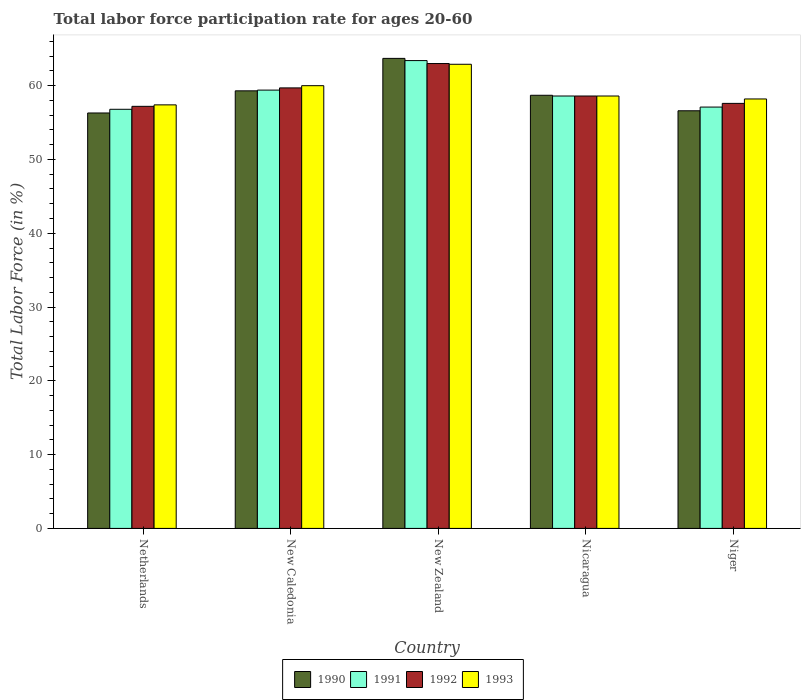How many different coloured bars are there?
Keep it short and to the point. 4. How many groups of bars are there?
Give a very brief answer. 5. Are the number of bars per tick equal to the number of legend labels?
Your response must be concise. Yes. How many bars are there on the 3rd tick from the right?
Provide a short and direct response. 4. What is the label of the 1st group of bars from the left?
Your answer should be very brief. Netherlands. In how many cases, is the number of bars for a given country not equal to the number of legend labels?
Your answer should be very brief. 0. What is the labor force participation rate in 1990 in New Zealand?
Offer a terse response. 63.7. Across all countries, what is the maximum labor force participation rate in 1990?
Keep it short and to the point. 63.7. Across all countries, what is the minimum labor force participation rate in 1991?
Offer a very short reply. 56.8. In which country was the labor force participation rate in 1993 maximum?
Offer a terse response. New Zealand. What is the total labor force participation rate in 1990 in the graph?
Make the answer very short. 294.6. What is the difference between the labor force participation rate in 1990 in New Caledonia and that in Nicaragua?
Your answer should be compact. 0.6. What is the difference between the labor force participation rate in 1990 in Niger and the labor force participation rate in 1992 in New Caledonia?
Offer a terse response. -3.1. What is the average labor force participation rate in 1990 per country?
Give a very brief answer. 58.92. What is the difference between the labor force participation rate of/in 1990 and labor force participation rate of/in 1993 in New Zealand?
Ensure brevity in your answer.  0.8. What is the ratio of the labor force participation rate in 1991 in Netherlands to that in Niger?
Offer a very short reply. 0.99. What is the difference between the highest and the second highest labor force participation rate in 1991?
Your answer should be very brief. -0.8. Is it the case that in every country, the sum of the labor force participation rate in 1993 and labor force participation rate in 1991 is greater than the sum of labor force participation rate in 1992 and labor force participation rate in 1990?
Your answer should be very brief. No. How many bars are there?
Your response must be concise. 20. Are all the bars in the graph horizontal?
Offer a terse response. No. How many countries are there in the graph?
Ensure brevity in your answer.  5. What is the difference between two consecutive major ticks on the Y-axis?
Offer a terse response. 10. Does the graph contain any zero values?
Offer a very short reply. No. Where does the legend appear in the graph?
Offer a terse response. Bottom center. How many legend labels are there?
Your answer should be compact. 4. What is the title of the graph?
Keep it short and to the point. Total labor force participation rate for ages 20-60. Does "2008" appear as one of the legend labels in the graph?
Offer a very short reply. No. What is the Total Labor Force (in %) of 1990 in Netherlands?
Ensure brevity in your answer.  56.3. What is the Total Labor Force (in %) of 1991 in Netherlands?
Give a very brief answer. 56.8. What is the Total Labor Force (in %) in 1992 in Netherlands?
Your response must be concise. 57.2. What is the Total Labor Force (in %) in 1993 in Netherlands?
Offer a very short reply. 57.4. What is the Total Labor Force (in %) in 1990 in New Caledonia?
Your response must be concise. 59.3. What is the Total Labor Force (in %) in 1991 in New Caledonia?
Your answer should be very brief. 59.4. What is the Total Labor Force (in %) in 1992 in New Caledonia?
Offer a terse response. 59.7. What is the Total Labor Force (in %) of 1990 in New Zealand?
Provide a short and direct response. 63.7. What is the Total Labor Force (in %) in 1991 in New Zealand?
Offer a terse response. 63.4. What is the Total Labor Force (in %) of 1992 in New Zealand?
Offer a terse response. 63. What is the Total Labor Force (in %) in 1993 in New Zealand?
Offer a terse response. 62.9. What is the Total Labor Force (in %) of 1990 in Nicaragua?
Ensure brevity in your answer.  58.7. What is the Total Labor Force (in %) in 1991 in Nicaragua?
Offer a terse response. 58.6. What is the Total Labor Force (in %) of 1992 in Nicaragua?
Give a very brief answer. 58.6. What is the Total Labor Force (in %) in 1993 in Nicaragua?
Your answer should be compact. 58.6. What is the Total Labor Force (in %) in 1990 in Niger?
Your response must be concise. 56.6. What is the Total Labor Force (in %) of 1991 in Niger?
Offer a very short reply. 57.1. What is the Total Labor Force (in %) of 1992 in Niger?
Keep it short and to the point. 57.6. What is the Total Labor Force (in %) in 1993 in Niger?
Offer a very short reply. 58.2. Across all countries, what is the maximum Total Labor Force (in %) in 1990?
Make the answer very short. 63.7. Across all countries, what is the maximum Total Labor Force (in %) of 1991?
Keep it short and to the point. 63.4. Across all countries, what is the maximum Total Labor Force (in %) in 1992?
Offer a terse response. 63. Across all countries, what is the maximum Total Labor Force (in %) of 1993?
Your response must be concise. 62.9. Across all countries, what is the minimum Total Labor Force (in %) in 1990?
Keep it short and to the point. 56.3. Across all countries, what is the minimum Total Labor Force (in %) of 1991?
Your answer should be compact. 56.8. Across all countries, what is the minimum Total Labor Force (in %) in 1992?
Offer a terse response. 57.2. Across all countries, what is the minimum Total Labor Force (in %) in 1993?
Your response must be concise. 57.4. What is the total Total Labor Force (in %) of 1990 in the graph?
Offer a terse response. 294.6. What is the total Total Labor Force (in %) in 1991 in the graph?
Your answer should be compact. 295.3. What is the total Total Labor Force (in %) of 1992 in the graph?
Ensure brevity in your answer.  296.1. What is the total Total Labor Force (in %) of 1993 in the graph?
Provide a succinct answer. 297.1. What is the difference between the Total Labor Force (in %) in 1991 in Netherlands and that in New Caledonia?
Offer a very short reply. -2.6. What is the difference between the Total Labor Force (in %) of 1993 in Netherlands and that in New Zealand?
Offer a very short reply. -5.5. What is the difference between the Total Labor Force (in %) of 1991 in Netherlands and that in Nicaragua?
Offer a very short reply. -1.8. What is the difference between the Total Labor Force (in %) in 1992 in Netherlands and that in Nicaragua?
Provide a short and direct response. -1.4. What is the difference between the Total Labor Force (in %) in 1991 in Netherlands and that in Niger?
Keep it short and to the point. -0.3. What is the difference between the Total Labor Force (in %) of 1990 in New Caledonia and that in New Zealand?
Make the answer very short. -4.4. What is the difference between the Total Labor Force (in %) of 1992 in New Caledonia and that in New Zealand?
Offer a very short reply. -3.3. What is the difference between the Total Labor Force (in %) in 1993 in New Caledonia and that in New Zealand?
Offer a terse response. -2.9. What is the difference between the Total Labor Force (in %) in 1991 in New Caledonia and that in Nicaragua?
Your response must be concise. 0.8. What is the difference between the Total Labor Force (in %) of 1993 in New Caledonia and that in Nicaragua?
Your answer should be very brief. 1.4. What is the difference between the Total Labor Force (in %) of 1990 in New Caledonia and that in Niger?
Offer a terse response. 2.7. What is the difference between the Total Labor Force (in %) in 1993 in New Caledonia and that in Niger?
Offer a very short reply. 1.8. What is the difference between the Total Labor Force (in %) in 1990 in New Zealand and that in Nicaragua?
Make the answer very short. 5. What is the difference between the Total Labor Force (in %) in 1991 in New Zealand and that in Nicaragua?
Your response must be concise. 4.8. What is the difference between the Total Labor Force (in %) of 1993 in New Zealand and that in Nicaragua?
Ensure brevity in your answer.  4.3. What is the difference between the Total Labor Force (in %) of 1990 in New Zealand and that in Niger?
Offer a very short reply. 7.1. What is the difference between the Total Labor Force (in %) in 1992 in New Zealand and that in Niger?
Your answer should be compact. 5.4. What is the difference between the Total Labor Force (in %) of 1993 in New Zealand and that in Niger?
Give a very brief answer. 4.7. What is the difference between the Total Labor Force (in %) in 1991 in Nicaragua and that in Niger?
Make the answer very short. 1.5. What is the difference between the Total Labor Force (in %) of 1990 in Netherlands and the Total Labor Force (in %) of 1992 in New Caledonia?
Provide a succinct answer. -3.4. What is the difference between the Total Labor Force (in %) of 1990 in Netherlands and the Total Labor Force (in %) of 1993 in New Caledonia?
Provide a succinct answer. -3.7. What is the difference between the Total Labor Force (in %) in 1992 in Netherlands and the Total Labor Force (in %) in 1993 in New Caledonia?
Offer a very short reply. -2.8. What is the difference between the Total Labor Force (in %) in 1991 in Netherlands and the Total Labor Force (in %) in 1992 in New Zealand?
Offer a terse response. -6.2. What is the difference between the Total Labor Force (in %) of 1990 in Netherlands and the Total Labor Force (in %) of 1991 in Nicaragua?
Give a very brief answer. -2.3. What is the difference between the Total Labor Force (in %) in 1990 in Netherlands and the Total Labor Force (in %) in 1993 in Nicaragua?
Your answer should be compact. -2.3. What is the difference between the Total Labor Force (in %) in 1992 in Netherlands and the Total Labor Force (in %) in 1993 in Nicaragua?
Offer a very short reply. -1.4. What is the difference between the Total Labor Force (in %) of 1990 in Netherlands and the Total Labor Force (in %) of 1992 in Niger?
Make the answer very short. -1.3. What is the difference between the Total Labor Force (in %) in 1990 in Netherlands and the Total Labor Force (in %) in 1993 in Niger?
Your response must be concise. -1.9. What is the difference between the Total Labor Force (in %) in 1991 in Netherlands and the Total Labor Force (in %) in 1992 in Niger?
Your answer should be compact. -0.8. What is the difference between the Total Labor Force (in %) of 1992 in Netherlands and the Total Labor Force (in %) of 1993 in Niger?
Offer a very short reply. -1. What is the difference between the Total Labor Force (in %) of 1990 in New Caledonia and the Total Labor Force (in %) of 1991 in New Zealand?
Provide a short and direct response. -4.1. What is the difference between the Total Labor Force (in %) in 1990 in New Caledonia and the Total Labor Force (in %) in 1992 in New Zealand?
Ensure brevity in your answer.  -3.7. What is the difference between the Total Labor Force (in %) in 1991 in New Caledonia and the Total Labor Force (in %) in 1992 in New Zealand?
Make the answer very short. -3.6. What is the difference between the Total Labor Force (in %) of 1991 in New Caledonia and the Total Labor Force (in %) of 1993 in New Zealand?
Offer a very short reply. -3.5. What is the difference between the Total Labor Force (in %) in 1992 in New Caledonia and the Total Labor Force (in %) in 1993 in New Zealand?
Make the answer very short. -3.2. What is the difference between the Total Labor Force (in %) of 1990 in New Caledonia and the Total Labor Force (in %) of 1991 in Nicaragua?
Provide a succinct answer. 0.7. What is the difference between the Total Labor Force (in %) of 1990 in New Caledonia and the Total Labor Force (in %) of 1993 in Nicaragua?
Make the answer very short. 0.7. What is the difference between the Total Labor Force (in %) of 1991 in New Caledonia and the Total Labor Force (in %) of 1993 in Nicaragua?
Your response must be concise. 0.8. What is the difference between the Total Labor Force (in %) in 1992 in New Caledonia and the Total Labor Force (in %) in 1993 in Nicaragua?
Give a very brief answer. 1.1. What is the difference between the Total Labor Force (in %) in 1990 in New Caledonia and the Total Labor Force (in %) in 1991 in Niger?
Your response must be concise. 2.2. What is the difference between the Total Labor Force (in %) of 1990 in New Caledonia and the Total Labor Force (in %) of 1992 in Niger?
Provide a short and direct response. 1.7. What is the difference between the Total Labor Force (in %) in 1992 in New Caledonia and the Total Labor Force (in %) in 1993 in Niger?
Provide a succinct answer. 1.5. What is the difference between the Total Labor Force (in %) of 1990 in New Zealand and the Total Labor Force (in %) of 1991 in Nicaragua?
Your answer should be very brief. 5.1. What is the difference between the Total Labor Force (in %) in 1990 in New Zealand and the Total Labor Force (in %) in 1992 in Nicaragua?
Your response must be concise. 5.1. What is the difference between the Total Labor Force (in %) in 1990 in New Zealand and the Total Labor Force (in %) in 1993 in Nicaragua?
Your response must be concise. 5.1. What is the difference between the Total Labor Force (in %) of 1991 in New Zealand and the Total Labor Force (in %) of 1993 in Nicaragua?
Make the answer very short. 4.8. What is the difference between the Total Labor Force (in %) of 1990 in New Zealand and the Total Labor Force (in %) of 1993 in Niger?
Your answer should be very brief. 5.5. What is the difference between the Total Labor Force (in %) in 1991 in New Zealand and the Total Labor Force (in %) in 1992 in Niger?
Provide a succinct answer. 5.8. What is the difference between the Total Labor Force (in %) of 1991 in New Zealand and the Total Labor Force (in %) of 1993 in Niger?
Your response must be concise. 5.2. What is the difference between the Total Labor Force (in %) in 1990 in Nicaragua and the Total Labor Force (in %) in 1991 in Niger?
Offer a very short reply. 1.6. What is the difference between the Total Labor Force (in %) in 1990 in Nicaragua and the Total Labor Force (in %) in 1992 in Niger?
Your response must be concise. 1.1. What is the difference between the Total Labor Force (in %) in 1990 in Nicaragua and the Total Labor Force (in %) in 1993 in Niger?
Your answer should be compact. 0.5. What is the difference between the Total Labor Force (in %) in 1991 in Nicaragua and the Total Labor Force (in %) in 1993 in Niger?
Your answer should be very brief. 0.4. What is the average Total Labor Force (in %) of 1990 per country?
Your response must be concise. 58.92. What is the average Total Labor Force (in %) of 1991 per country?
Give a very brief answer. 59.06. What is the average Total Labor Force (in %) in 1992 per country?
Give a very brief answer. 59.22. What is the average Total Labor Force (in %) of 1993 per country?
Keep it short and to the point. 59.42. What is the difference between the Total Labor Force (in %) in 1990 and Total Labor Force (in %) in 1991 in Netherlands?
Make the answer very short. -0.5. What is the difference between the Total Labor Force (in %) in 1990 and Total Labor Force (in %) in 1992 in Netherlands?
Ensure brevity in your answer.  -0.9. What is the difference between the Total Labor Force (in %) of 1990 and Total Labor Force (in %) of 1993 in Netherlands?
Give a very brief answer. -1.1. What is the difference between the Total Labor Force (in %) in 1990 and Total Labor Force (in %) in 1992 in New Caledonia?
Ensure brevity in your answer.  -0.4. What is the difference between the Total Labor Force (in %) of 1990 and Total Labor Force (in %) of 1993 in New Caledonia?
Offer a terse response. -0.7. What is the difference between the Total Labor Force (in %) in 1991 and Total Labor Force (in %) in 1992 in New Zealand?
Keep it short and to the point. 0.4. What is the difference between the Total Labor Force (in %) in 1991 and Total Labor Force (in %) in 1992 in Nicaragua?
Ensure brevity in your answer.  0. What is the difference between the Total Labor Force (in %) in 1991 and Total Labor Force (in %) in 1993 in Nicaragua?
Your answer should be very brief. 0. What is the difference between the Total Labor Force (in %) of 1992 and Total Labor Force (in %) of 1993 in Nicaragua?
Offer a terse response. 0. What is the difference between the Total Labor Force (in %) of 1990 and Total Labor Force (in %) of 1991 in Niger?
Keep it short and to the point. -0.5. What is the ratio of the Total Labor Force (in %) of 1990 in Netherlands to that in New Caledonia?
Your response must be concise. 0.95. What is the ratio of the Total Labor Force (in %) of 1991 in Netherlands to that in New Caledonia?
Provide a succinct answer. 0.96. What is the ratio of the Total Labor Force (in %) in 1992 in Netherlands to that in New Caledonia?
Provide a succinct answer. 0.96. What is the ratio of the Total Labor Force (in %) in 1993 in Netherlands to that in New Caledonia?
Give a very brief answer. 0.96. What is the ratio of the Total Labor Force (in %) in 1990 in Netherlands to that in New Zealand?
Provide a short and direct response. 0.88. What is the ratio of the Total Labor Force (in %) in 1991 in Netherlands to that in New Zealand?
Provide a succinct answer. 0.9. What is the ratio of the Total Labor Force (in %) of 1992 in Netherlands to that in New Zealand?
Offer a very short reply. 0.91. What is the ratio of the Total Labor Force (in %) in 1993 in Netherlands to that in New Zealand?
Provide a short and direct response. 0.91. What is the ratio of the Total Labor Force (in %) of 1990 in Netherlands to that in Nicaragua?
Keep it short and to the point. 0.96. What is the ratio of the Total Labor Force (in %) in 1991 in Netherlands to that in Nicaragua?
Your response must be concise. 0.97. What is the ratio of the Total Labor Force (in %) in 1992 in Netherlands to that in Nicaragua?
Make the answer very short. 0.98. What is the ratio of the Total Labor Force (in %) of 1993 in Netherlands to that in Nicaragua?
Provide a succinct answer. 0.98. What is the ratio of the Total Labor Force (in %) in 1990 in Netherlands to that in Niger?
Your answer should be compact. 0.99. What is the ratio of the Total Labor Force (in %) in 1993 in Netherlands to that in Niger?
Make the answer very short. 0.99. What is the ratio of the Total Labor Force (in %) of 1990 in New Caledonia to that in New Zealand?
Ensure brevity in your answer.  0.93. What is the ratio of the Total Labor Force (in %) in 1991 in New Caledonia to that in New Zealand?
Your answer should be very brief. 0.94. What is the ratio of the Total Labor Force (in %) in 1992 in New Caledonia to that in New Zealand?
Your answer should be very brief. 0.95. What is the ratio of the Total Labor Force (in %) of 1993 in New Caledonia to that in New Zealand?
Ensure brevity in your answer.  0.95. What is the ratio of the Total Labor Force (in %) in 1990 in New Caledonia to that in Nicaragua?
Your answer should be very brief. 1.01. What is the ratio of the Total Labor Force (in %) in 1991 in New Caledonia to that in Nicaragua?
Keep it short and to the point. 1.01. What is the ratio of the Total Labor Force (in %) in 1992 in New Caledonia to that in Nicaragua?
Offer a very short reply. 1.02. What is the ratio of the Total Labor Force (in %) in 1993 in New Caledonia to that in Nicaragua?
Your response must be concise. 1.02. What is the ratio of the Total Labor Force (in %) in 1990 in New Caledonia to that in Niger?
Provide a short and direct response. 1.05. What is the ratio of the Total Labor Force (in %) in 1991 in New Caledonia to that in Niger?
Offer a terse response. 1.04. What is the ratio of the Total Labor Force (in %) in 1992 in New Caledonia to that in Niger?
Give a very brief answer. 1.04. What is the ratio of the Total Labor Force (in %) in 1993 in New Caledonia to that in Niger?
Make the answer very short. 1.03. What is the ratio of the Total Labor Force (in %) in 1990 in New Zealand to that in Nicaragua?
Offer a terse response. 1.09. What is the ratio of the Total Labor Force (in %) in 1991 in New Zealand to that in Nicaragua?
Ensure brevity in your answer.  1.08. What is the ratio of the Total Labor Force (in %) of 1992 in New Zealand to that in Nicaragua?
Keep it short and to the point. 1.08. What is the ratio of the Total Labor Force (in %) of 1993 in New Zealand to that in Nicaragua?
Provide a short and direct response. 1.07. What is the ratio of the Total Labor Force (in %) of 1990 in New Zealand to that in Niger?
Your answer should be compact. 1.13. What is the ratio of the Total Labor Force (in %) in 1991 in New Zealand to that in Niger?
Offer a terse response. 1.11. What is the ratio of the Total Labor Force (in %) in 1992 in New Zealand to that in Niger?
Provide a short and direct response. 1.09. What is the ratio of the Total Labor Force (in %) of 1993 in New Zealand to that in Niger?
Offer a terse response. 1.08. What is the ratio of the Total Labor Force (in %) in 1990 in Nicaragua to that in Niger?
Keep it short and to the point. 1.04. What is the ratio of the Total Labor Force (in %) of 1991 in Nicaragua to that in Niger?
Your answer should be compact. 1.03. What is the ratio of the Total Labor Force (in %) in 1992 in Nicaragua to that in Niger?
Keep it short and to the point. 1.02. What is the ratio of the Total Labor Force (in %) in 1993 in Nicaragua to that in Niger?
Your answer should be compact. 1.01. What is the difference between the highest and the second highest Total Labor Force (in %) in 1990?
Keep it short and to the point. 4.4. What is the difference between the highest and the second highest Total Labor Force (in %) of 1991?
Your answer should be very brief. 4. What is the difference between the highest and the second highest Total Labor Force (in %) in 1992?
Provide a short and direct response. 3.3. What is the difference between the highest and the second highest Total Labor Force (in %) in 1993?
Give a very brief answer. 2.9. 